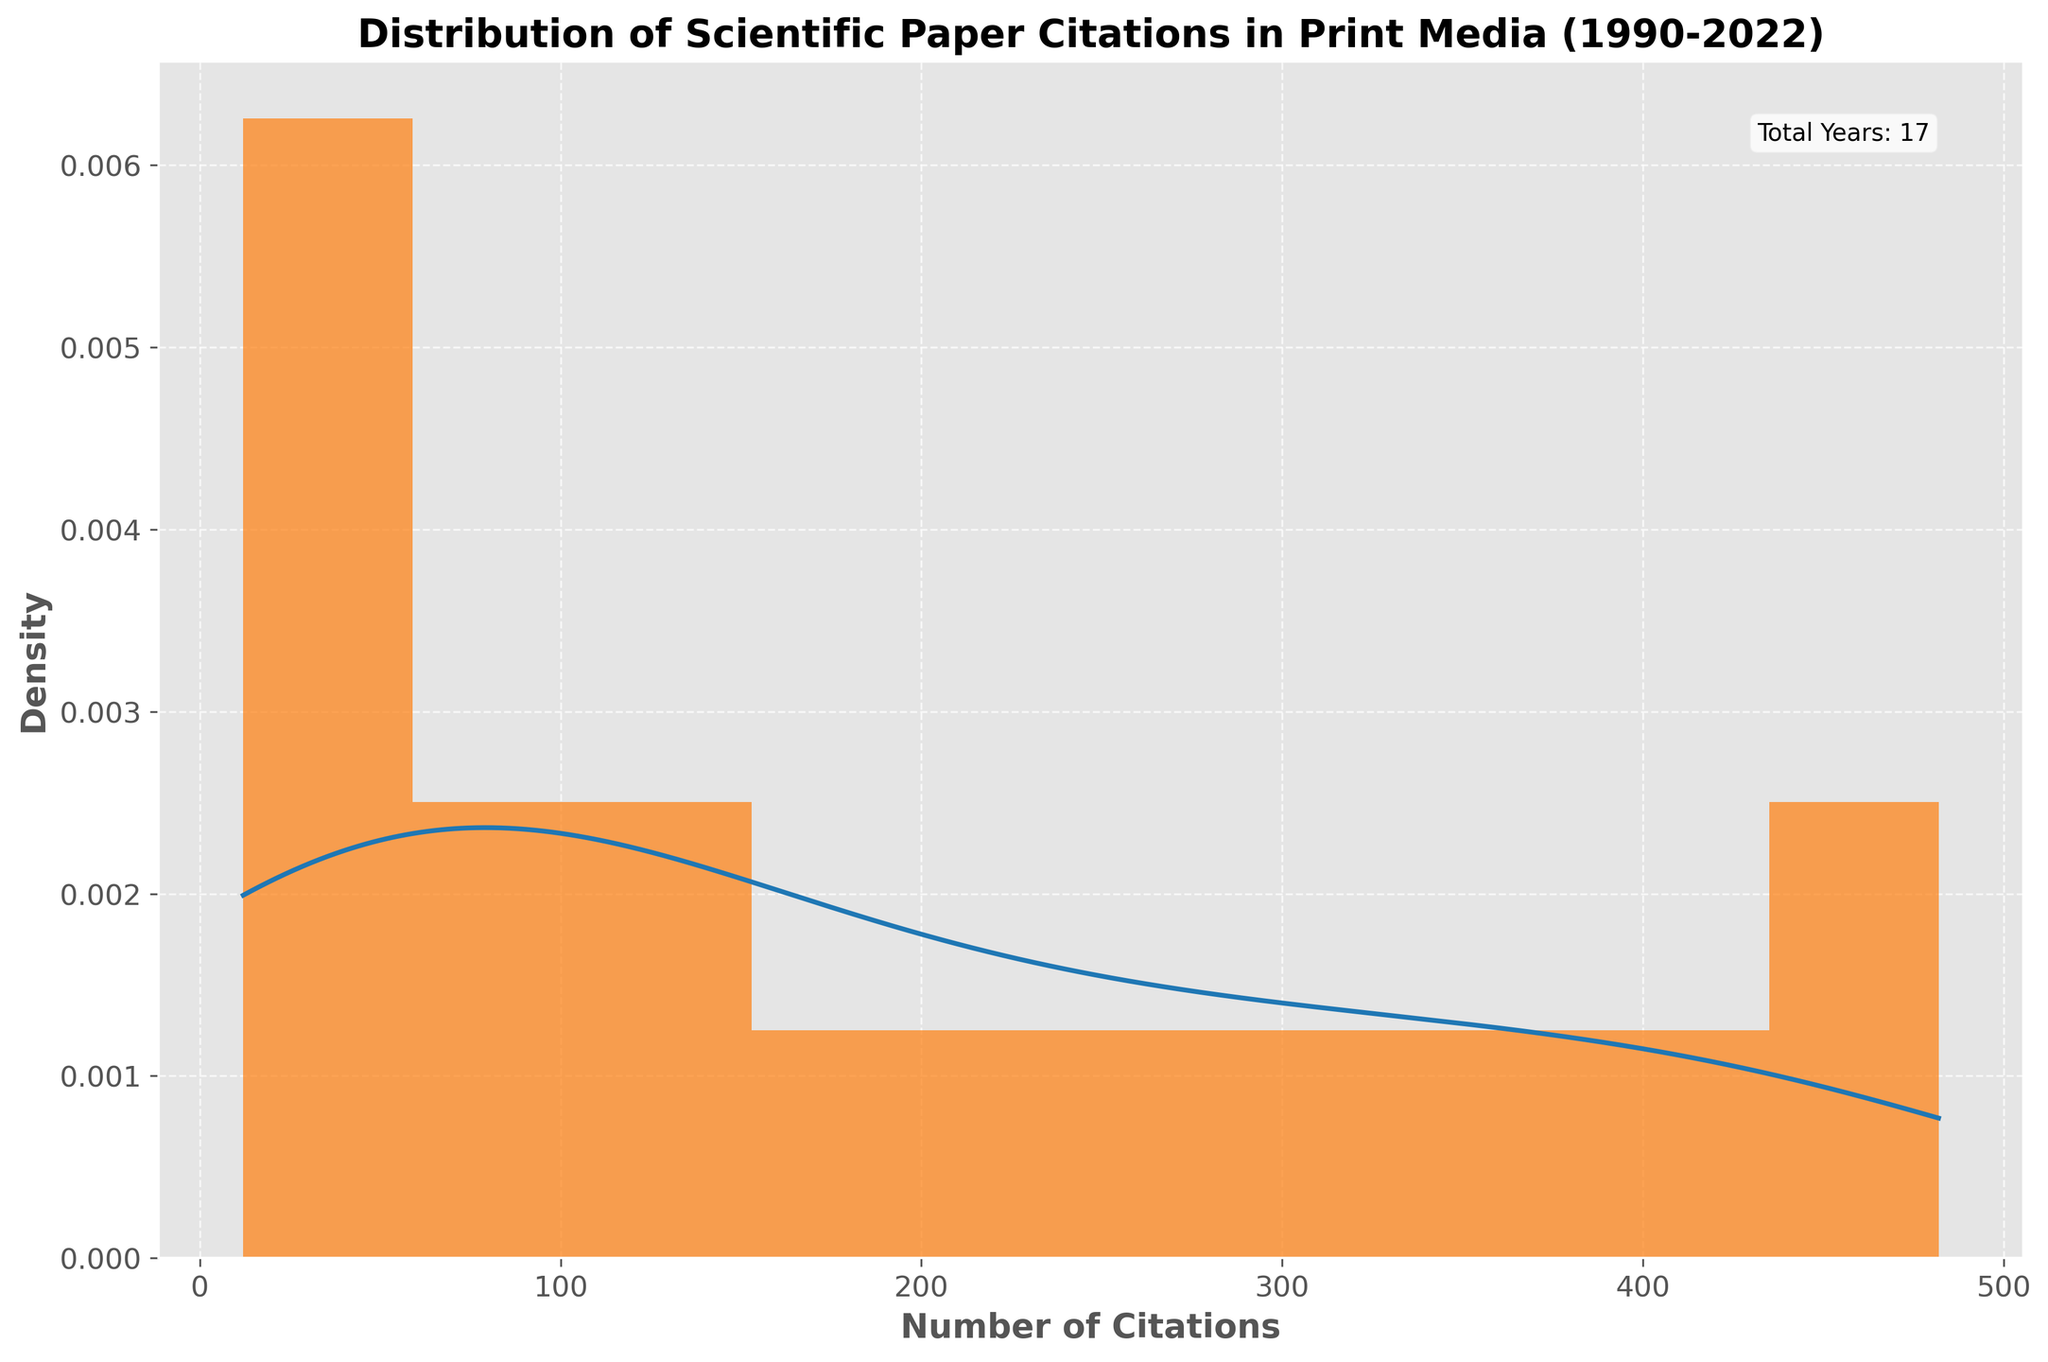What is the title of the figure? The title of the figure is positioned at the top and it summarizes the overall content represented in the plot. By looking at the top center of the figure, one can easily identify the title.
Answer: Distribution of Scientific Paper Citations in Print Media (1990-2022) How many bins are used in the histogram? The histogram displays data distribution and the number of bins can be counted by observing the division of the x-axis into sections filled with bars. By counting these sections, you can find the number of bins used.
Answer: 10 What is approximately the range of the number of citations shown on the x-axis? The range of the x-axis can be determined by looking at the smallest and largest values labeled along the x-axis. The histogram and KDE curve span this range and indicate the coverage of data on the x-axis.
Answer: 12 to 482 Is the histogram skewed, and if so, in which direction? Skewness can be assessed by examining the shape of the histogram. If the majority of the values are concentrated on one end, leaving a tail on the other, it indicates skewness. Here, most citations are on the lower end, with a long tail towards higher values.
Answer: Right-skewed Where does the peak of the KDE curve occur? The peak of the KDE curve represents the highest density of citations and can be identified by locating the highest point on the smooth blue curve. This peak indicates the most common citation value around which most data points are concentrated.
Answer: Near 100 citations Which section of the x-axis has the highest density of citations according to the histogram? The highest density in a histogram can be recognized by the tallest bar. The x-axis range covered by this tallest bar will indicate the section with the highest citation density.
Answer: 80-120 citations Approximately what is the width of each bin in the histogram? The width of each bin can be found by dividing the range of the x-axis by the number of bins. The x-axis range is approximately from 12 to 482, and with 10 bins, the calculation (482-12)/10 gives the bin width.
Answer: ~47 citations How does the density change as the number of citations increases? The KDE curve helps illustrate how density changes. By following the curve from left to right, one can observe the trend of the density: it starts high, peaks around 100, and then decreases steadily.
Answer: Decreases steadily Compare the citation frequency distribution before and after 200 citations. By examining the histogram bars and the KDE curve, one can compare the distribution before and after 200 citations; below 200, more bins have higher densities, while above 200, the density reduces to lower frequencies.
Answer: Higher below 200, lower above 200 What could be the possible significance of the KDE curve in this figure? The KDE curve provides a smooth estimate of the probability density function of the citation data, giving a better understanding of the underlying distribution of citations without the noise present in the histogram bars.
Answer: Shows a smooth probability density function 